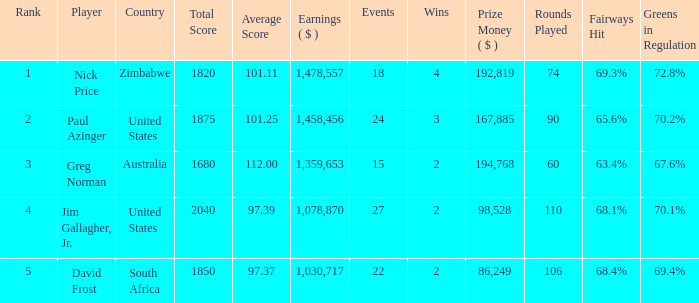How many events have earnings less than 1,030,717? 0.0. 